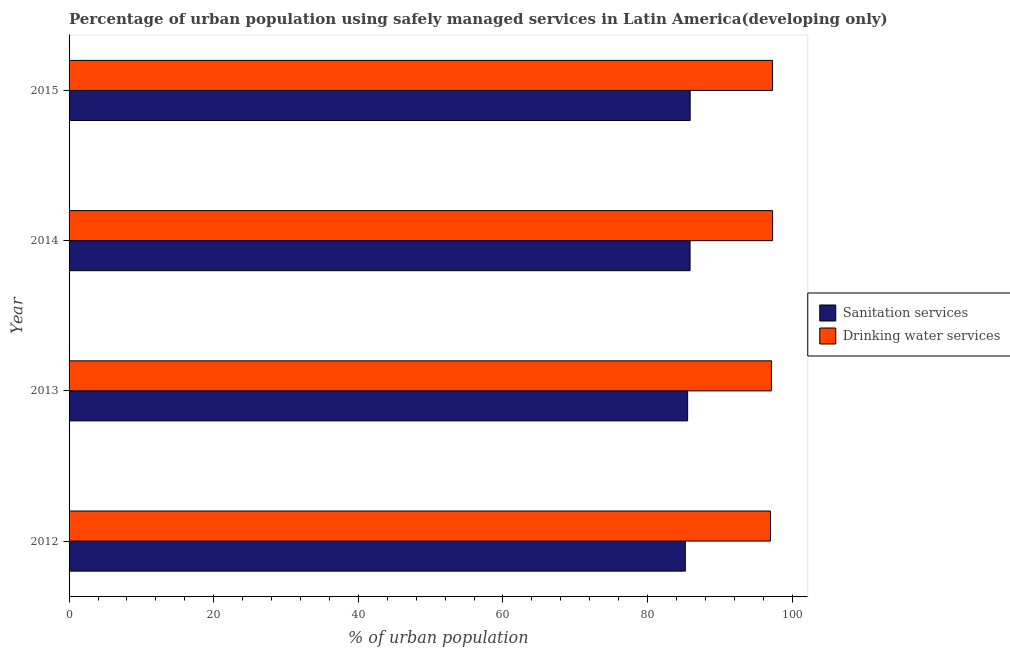How many different coloured bars are there?
Your response must be concise. 2. How many groups of bars are there?
Offer a very short reply. 4. Are the number of bars per tick equal to the number of legend labels?
Provide a succinct answer. Yes. What is the percentage of urban population who used drinking water services in 2013?
Your response must be concise. 97.13. Across all years, what is the maximum percentage of urban population who used sanitation services?
Provide a short and direct response. 85.89. Across all years, what is the minimum percentage of urban population who used drinking water services?
Give a very brief answer. 97. In which year was the percentage of urban population who used drinking water services maximum?
Make the answer very short. 2014. In which year was the percentage of urban population who used sanitation services minimum?
Your answer should be very brief. 2012. What is the total percentage of urban population who used drinking water services in the graph?
Provide a succinct answer. 388.7. What is the difference between the percentage of urban population who used sanitation services in 2012 and that in 2013?
Provide a short and direct response. -0.32. What is the difference between the percentage of urban population who used drinking water services in 2013 and the percentage of urban population who used sanitation services in 2015?
Provide a succinct answer. 11.24. What is the average percentage of urban population who used sanitation services per year?
Ensure brevity in your answer.  85.63. In the year 2012, what is the difference between the percentage of urban population who used sanitation services and percentage of urban population who used drinking water services?
Make the answer very short. -11.78. Is the percentage of urban population who used sanitation services in 2013 less than that in 2015?
Provide a short and direct response. Yes. What is the difference between the highest and the second highest percentage of urban population who used drinking water services?
Provide a short and direct response. 0.01. What is the difference between the highest and the lowest percentage of urban population who used drinking water services?
Give a very brief answer. 0.29. In how many years, is the percentage of urban population who used drinking water services greater than the average percentage of urban population who used drinking water services taken over all years?
Provide a succinct answer. 2. Is the sum of the percentage of urban population who used sanitation services in 2012 and 2013 greater than the maximum percentage of urban population who used drinking water services across all years?
Provide a short and direct response. Yes. What does the 1st bar from the top in 2013 represents?
Offer a terse response. Drinking water services. What does the 1st bar from the bottom in 2012 represents?
Keep it short and to the point. Sanitation services. Are all the bars in the graph horizontal?
Offer a terse response. Yes. How many years are there in the graph?
Provide a short and direct response. 4. Are the values on the major ticks of X-axis written in scientific E-notation?
Provide a short and direct response. No. Does the graph contain grids?
Offer a terse response. No. How are the legend labels stacked?
Keep it short and to the point. Vertical. What is the title of the graph?
Your answer should be very brief. Percentage of urban population using safely managed services in Latin America(developing only). What is the label or title of the X-axis?
Offer a very short reply. % of urban population. What is the label or title of the Y-axis?
Ensure brevity in your answer.  Year. What is the % of urban population in Sanitation services in 2012?
Provide a succinct answer. 85.23. What is the % of urban population in Drinking water services in 2012?
Keep it short and to the point. 97. What is the % of urban population of Sanitation services in 2013?
Your answer should be compact. 85.54. What is the % of urban population of Drinking water services in 2013?
Your response must be concise. 97.13. What is the % of urban population in Sanitation services in 2014?
Ensure brevity in your answer.  85.87. What is the % of urban population in Drinking water services in 2014?
Offer a terse response. 97.29. What is the % of urban population in Sanitation services in 2015?
Offer a very short reply. 85.89. What is the % of urban population of Drinking water services in 2015?
Your answer should be compact. 97.28. Across all years, what is the maximum % of urban population in Sanitation services?
Offer a very short reply. 85.89. Across all years, what is the maximum % of urban population in Drinking water services?
Your response must be concise. 97.29. Across all years, what is the minimum % of urban population of Sanitation services?
Offer a very short reply. 85.23. Across all years, what is the minimum % of urban population of Drinking water services?
Keep it short and to the point. 97. What is the total % of urban population in Sanitation services in the graph?
Your answer should be very brief. 342.53. What is the total % of urban population in Drinking water services in the graph?
Offer a terse response. 388.7. What is the difference between the % of urban population of Sanitation services in 2012 and that in 2013?
Keep it short and to the point. -0.32. What is the difference between the % of urban population of Drinking water services in 2012 and that in 2013?
Your answer should be compact. -0.13. What is the difference between the % of urban population of Sanitation services in 2012 and that in 2014?
Make the answer very short. -0.65. What is the difference between the % of urban population in Drinking water services in 2012 and that in 2014?
Offer a terse response. -0.29. What is the difference between the % of urban population of Sanitation services in 2012 and that in 2015?
Ensure brevity in your answer.  -0.67. What is the difference between the % of urban population in Drinking water services in 2012 and that in 2015?
Offer a terse response. -0.28. What is the difference between the % of urban population in Sanitation services in 2013 and that in 2014?
Ensure brevity in your answer.  -0.33. What is the difference between the % of urban population in Drinking water services in 2013 and that in 2014?
Ensure brevity in your answer.  -0.15. What is the difference between the % of urban population in Sanitation services in 2013 and that in 2015?
Offer a very short reply. -0.35. What is the difference between the % of urban population in Drinking water services in 2013 and that in 2015?
Give a very brief answer. -0.14. What is the difference between the % of urban population in Sanitation services in 2014 and that in 2015?
Offer a very short reply. -0.02. What is the difference between the % of urban population of Drinking water services in 2014 and that in 2015?
Ensure brevity in your answer.  0.01. What is the difference between the % of urban population in Sanitation services in 2012 and the % of urban population in Drinking water services in 2013?
Provide a succinct answer. -11.91. What is the difference between the % of urban population of Sanitation services in 2012 and the % of urban population of Drinking water services in 2014?
Offer a very short reply. -12.06. What is the difference between the % of urban population in Sanitation services in 2012 and the % of urban population in Drinking water services in 2015?
Your answer should be compact. -12.05. What is the difference between the % of urban population of Sanitation services in 2013 and the % of urban population of Drinking water services in 2014?
Offer a very short reply. -11.75. What is the difference between the % of urban population in Sanitation services in 2013 and the % of urban population in Drinking water services in 2015?
Provide a succinct answer. -11.74. What is the difference between the % of urban population in Sanitation services in 2014 and the % of urban population in Drinking water services in 2015?
Your answer should be compact. -11.4. What is the average % of urban population of Sanitation services per year?
Provide a short and direct response. 85.63. What is the average % of urban population in Drinking water services per year?
Your answer should be compact. 97.18. In the year 2012, what is the difference between the % of urban population of Sanitation services and % of urban population of Drinking water services?
Offer a terse response. -11.78. In the year 2013, what is the difference between the % of urban population of Sanitation services and % of urban population of Drinking water services?
Your response must be concise. -11.59. In the year 2014, what is the difference between the % of urban population of Sanitation services and % of urban population of Drinking water services?
Your answer should be very brief. -11.41. In the year 2015, what is the difference between the % of urban population of Sanitation services and % of urban population of Drinking water services?
Your answer should be compact. -11.39. What is the ratio of the % of urban population in Sanitation services in 2012 to that in 2013?
Ensure brevity in your answer.  1. What is the ratio of the % of urban population of Drinking water services in 2012 to that in 2013?
Offer a terse response. 1. What is the ratio of the % of urban population in Sanitation services in 2012 to that in 2014?
Provide a succinct answer. 0.99. What is the ratio of the % of urban population of Drinking water services in 2012 to that in 2015?
Your response must be concise. 1. What is the ratio of the % of urban population of Sanitation services in 2013 to that in 2014?
Keep it short and to the point. 1. What is the ratio of the % of urban population in Drinking water services in 2013 to that in 2014?
Your answer should be very brief. 1. What is the ratio of the % of urban population of Sanitation services in 2013 to that in 2015?
Your answer should be compact. 1. What is the ratio of the % of urban population in Sanitation services in 2014 to that in 2015?
Keep it short and to the point. 1. What is the difference between the highest and the second highest % of urban population of Sanitation services?
Your response must be concise. 0.02. What is the difference between the highest and the second highest % of urban population of Drinking water services?
Offer a very short reply. 0.01. What is the difference between the highest and the lowest % of urban population in Sanitation services?
Your answer should be compact. 0.67. What is the difference between the highest and the lowest % of urban population in Drinking water services?
Your answer should be compact. 0.29. 